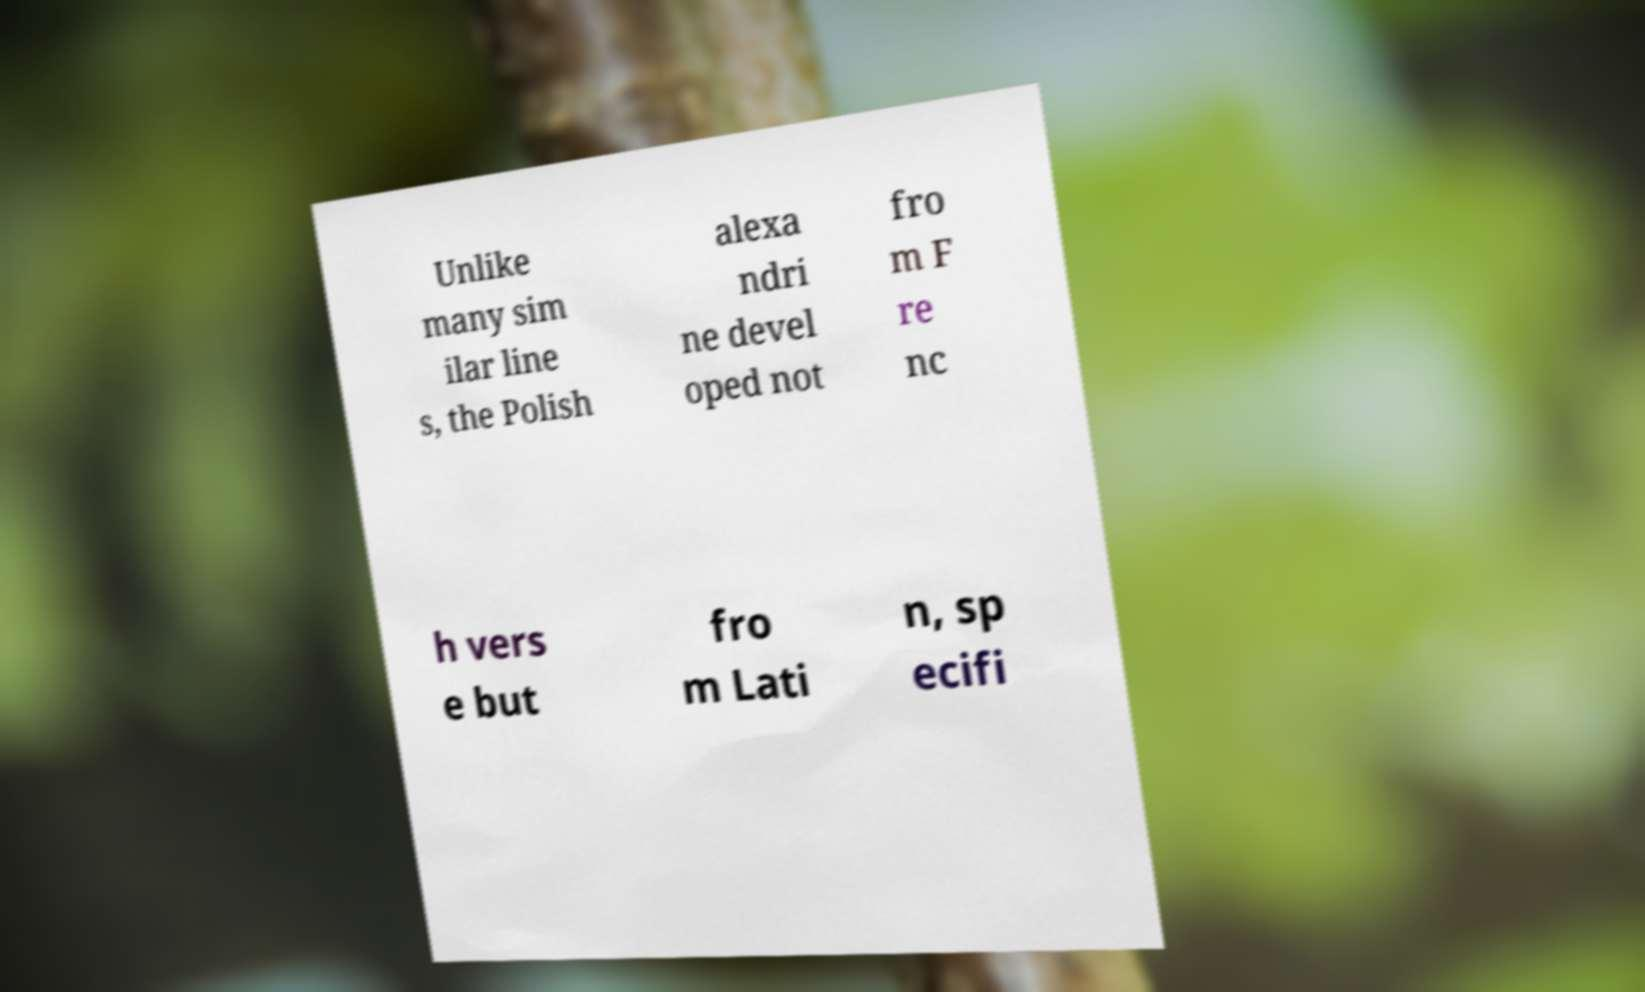For documentation purposes, I need the text within this image transcribed. Could you provide that? Unlike many sim ilar line s, the Polish alexa ndri ne devel oped not fro m F re nc h vers e but fro m Lati n, sp ecifi 